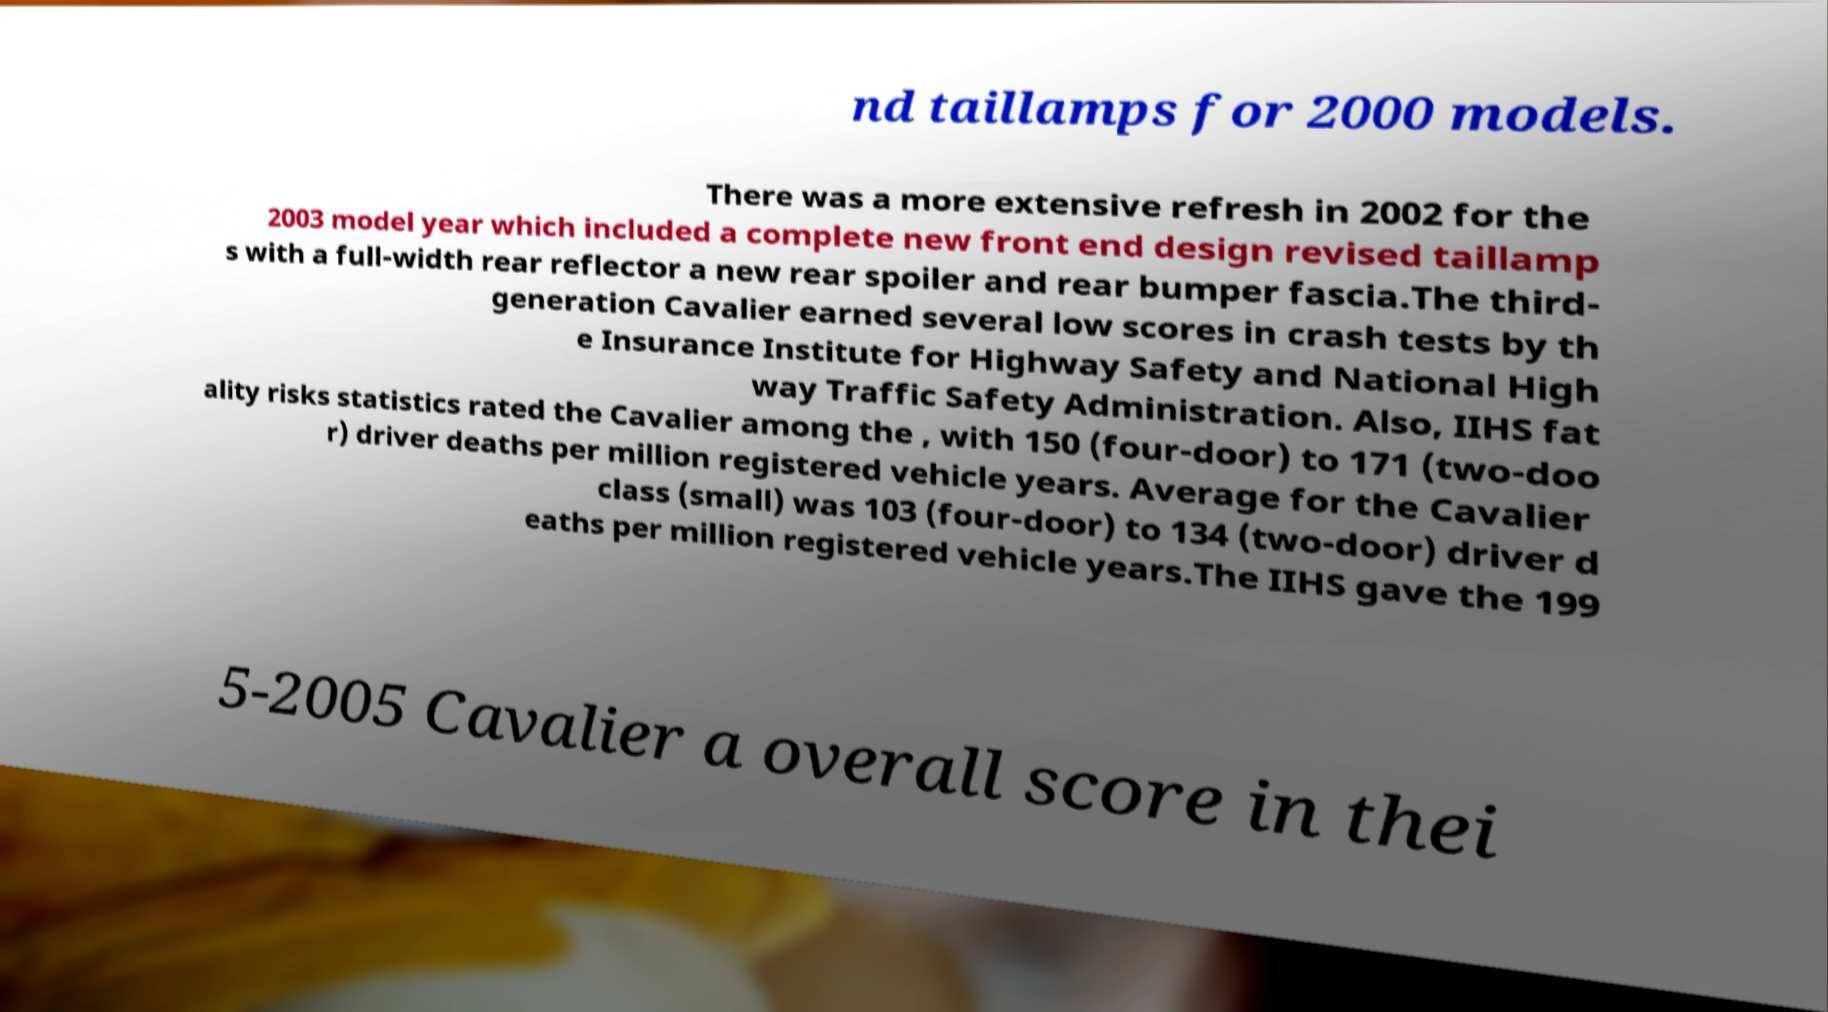What messages or text are displayed in this image? I need them in a readable, typed format. nd taillamps for 2000 models. There was a more extensive refresh in 2002 for the 2003 model year which included a complete new front end design revised taillamp s with a full-width rear reflector a new rear spoiler and rear bumper fascia.The third- generation Cavalier earned several low scores in crash tests by th e Insurance Institute for Highway Safety and National High way Traffic Safety Administration. Also, IIHS fat ality risks statistics rated the Cavalier among the , with 150 (four-door) to 171 (two-doo r) driver deaths per million registered vehicle years. Average for the Cavalier class (small) was 103 (four-door) to 134 (two-door) driver d eaths per million registered vehicle years.The IIHS gave the 199 5-2005 Cavalier a overall score in thei 